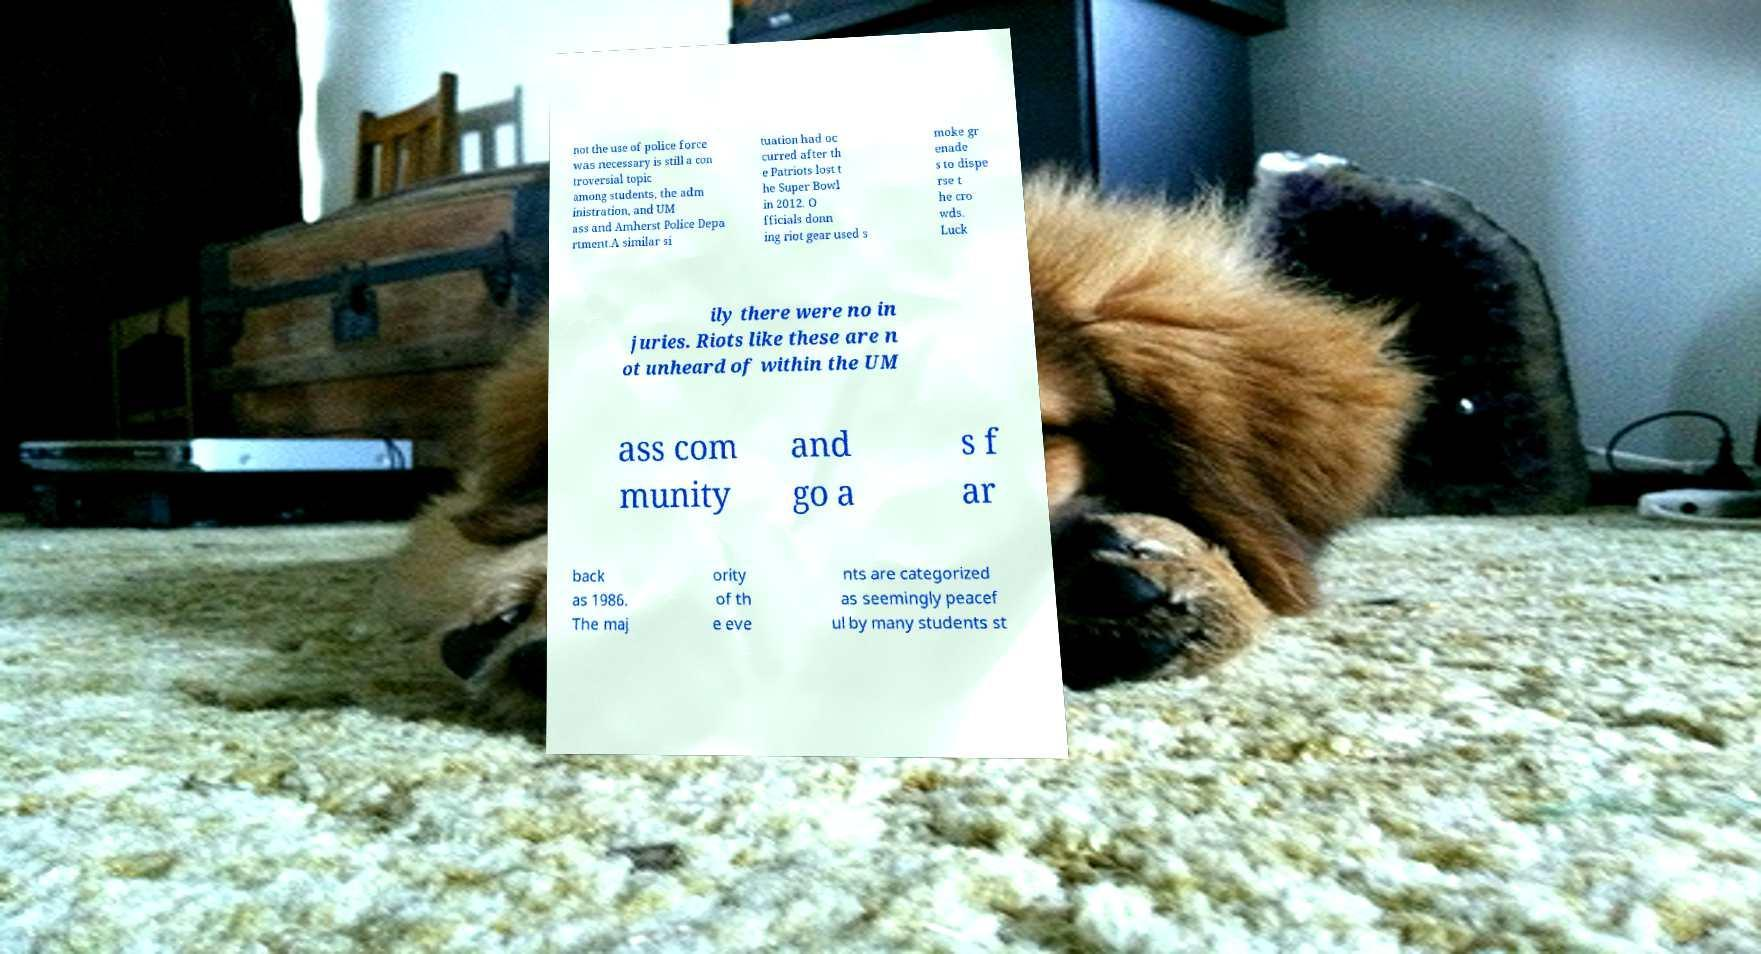What messages or text are displayed in this image? I need them in a readable, typed format. not the use of police force was necessary is still a con troversial topic among students, the adm inistration, and UM ass and Amherst Police Depa rtment.A similar si tuation had oc curred after th e Patriots lost t he Super Bowl in 2012. O fficials donn ing riot gear used s moke gr enade s to dispe rse t he cro wds. Luck ily there were no in juries. Riots like these are n ot unheard of within the UM ass com munity and go a s f ar back as 1986. The maj ority of th e eve nts are categorized as seemingly peacef ul by many students st 